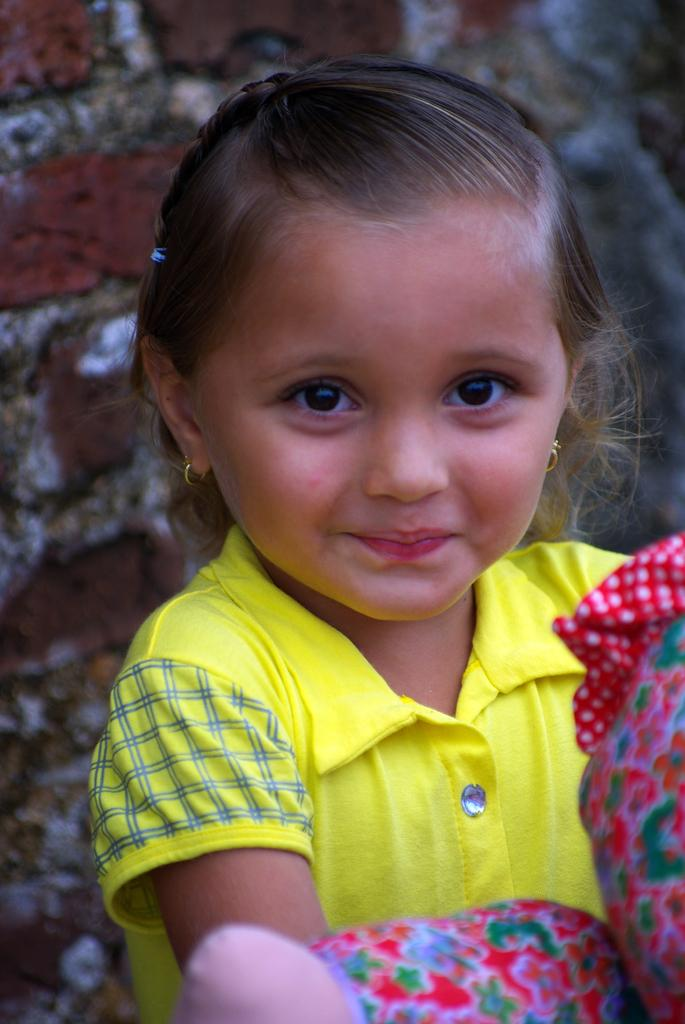What is the main subject of the image? There is a kid in the center of the image. What is the kid holding in the image? The kid is holding an object. What is the emotional expression of the kid in the image? The kid is smiling. What color is the top that the kid is wearing? The kid is wearing a yellow top. What can be seen in the background of the image? There is a brick wall in the background of the image. How does the force of gravity affect the balloon in the image? There is no balloon present in the image, so the force of gravity cannot be observed acting upon it. What type of rub is the kid applying to the wall in the image? There is no rub or any indication of the kid interacting with the wall in the image. 